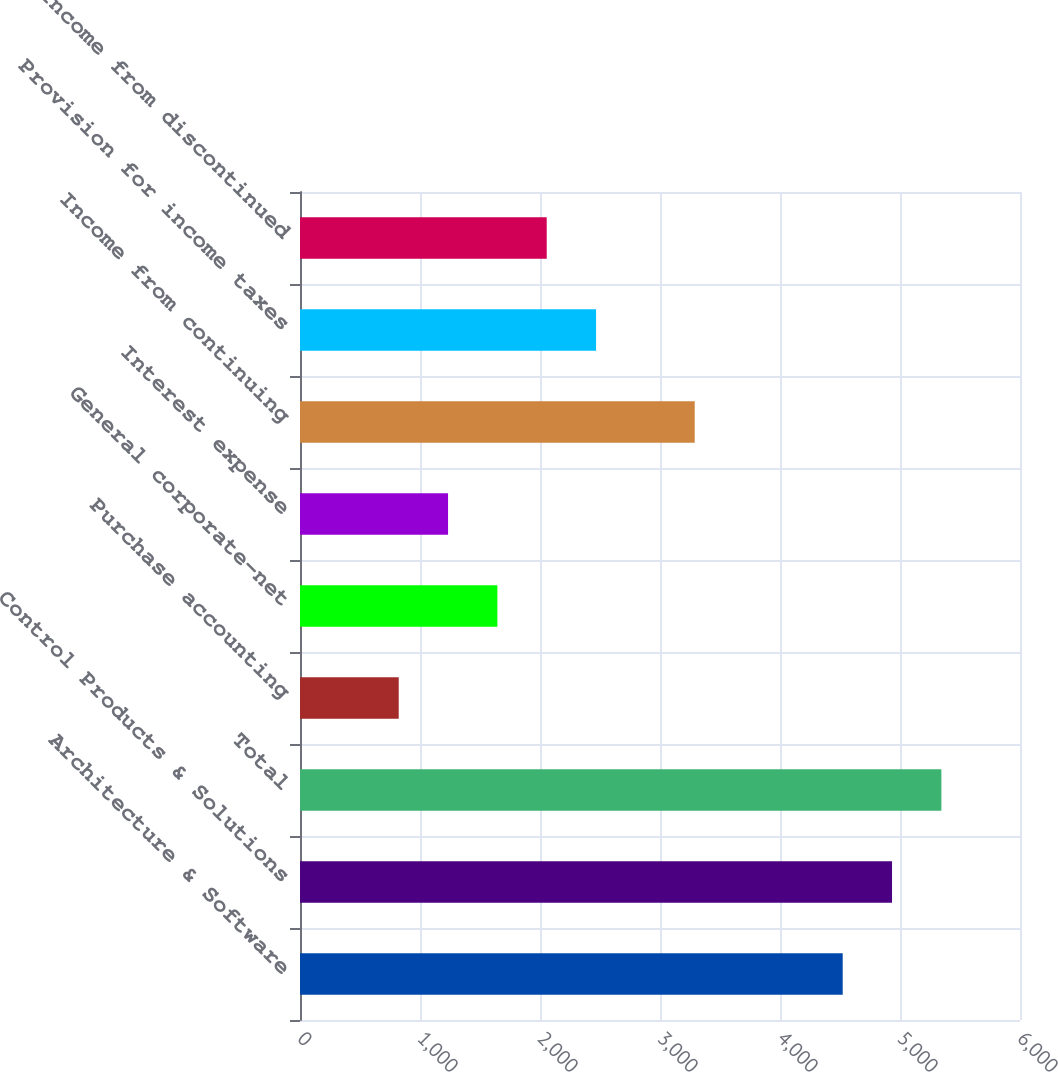Convert chart. <chart><loc_0><loc_0><loc_500><loc_500><bar_chart><fcel>Architecture & Software<fcel>Control Products & Solutions<fcel>Total<fcel>Purchase accounting<fcel>General corporate-net<fcel>Interest expense<fcel>Income from continuing<fcel>Provision for income taxes<fcel>Income from discontinued<nl><fcel>4522.59<fcel>4933.69<fcel>5344.79<fcel>822.69<fcel>1644.89<fcel>1233.79<fcel>3289.29<fcel>2467.09<fcel>2055.99<nl></chart> 